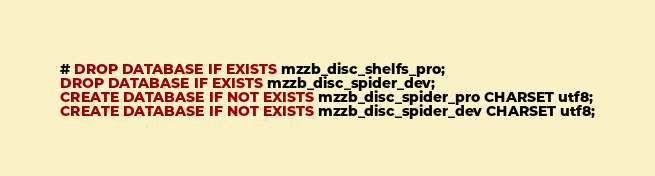<code> <loc_0><loc_0><loc_500><loc_500><_SQL_># DROP DATABASE IF EXISTS mzzb_disc_shelfs_pro;
DROP DATABASE IF EXISTS mzzb_disc_spider_dev;
CREATE DATABASE IF NOT EXISTS mzzb_disc_spider_pro CHARSET utf8;
CREATE DATABASE IF NOT EXISTS mzzb_disc_spider_dev CHARSET utf8;
</code> 